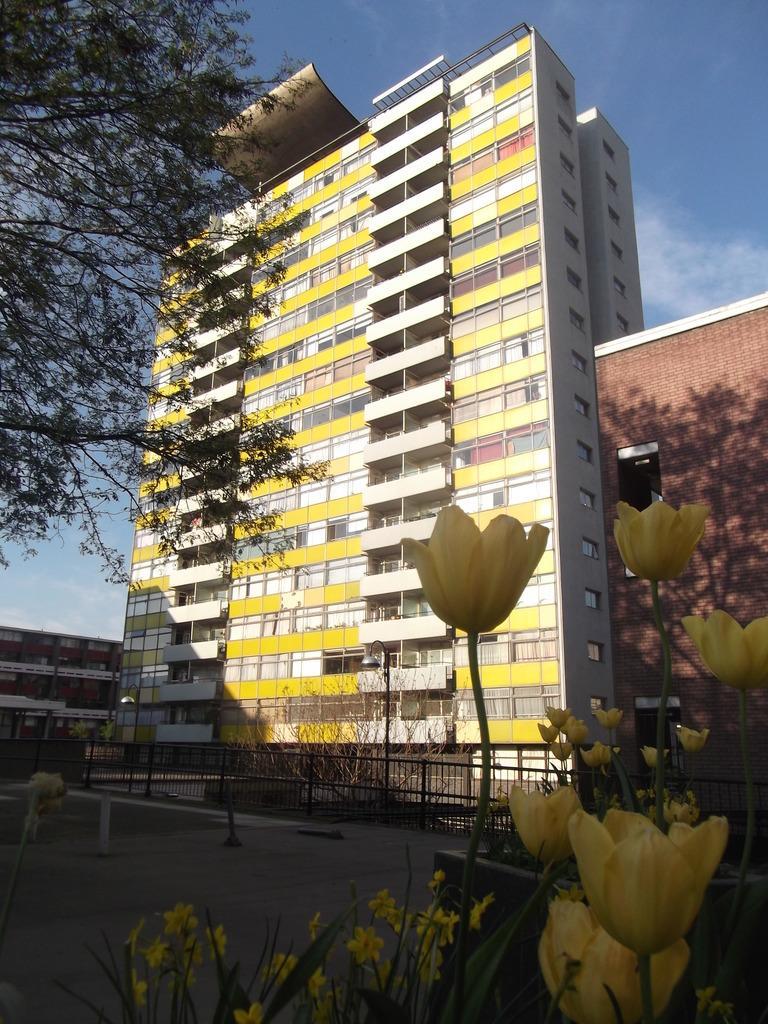How would you summarize this image in a sentence or two? In this image, in the right corner, we can see some flowers which are in yellow color. In the middle of the image, we can see some plants with flowers. On the left side, we can see some trees. In the background, we can see a building, window. At the top, we can see a sky which is a bit cloudy, at the bottom, we can see some plants, metal grill and a road. 